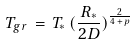<formula> <loc_0><loc_0><loc_500><loc_500>T _ { g r } \, = \, T _ { * } \, ( \frac { R _ { * } } { 2 D } ) ^ { \frac { 2 } { 4 \, + \, p } }</formula> 